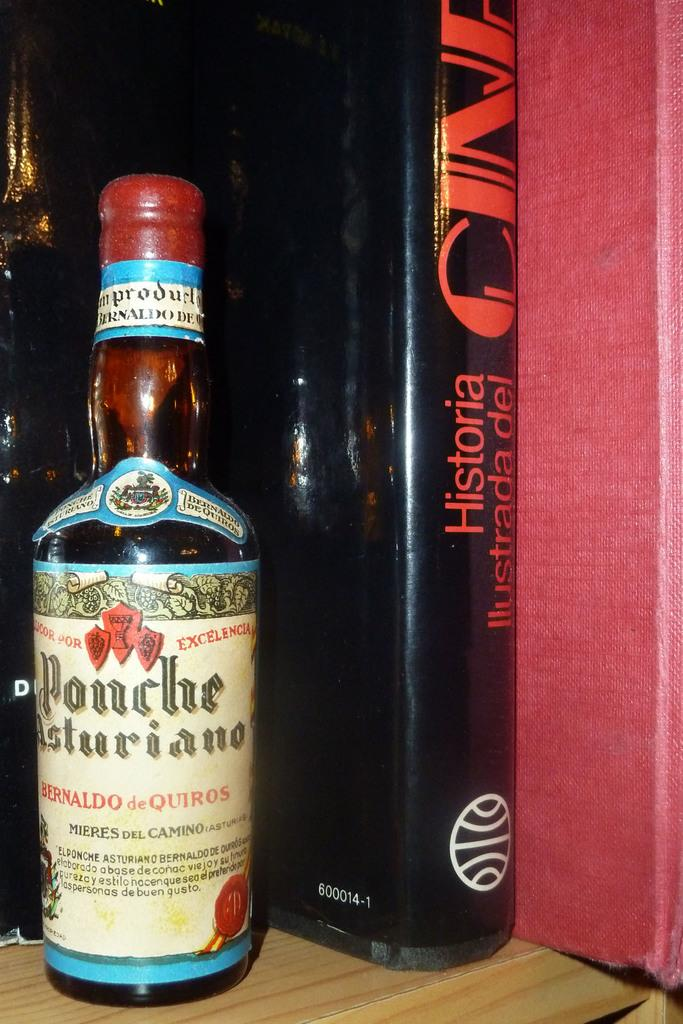<image>
Provide a brief description of the given image. A bottle of Ponche Asturiano sits by a book on a shelf. 